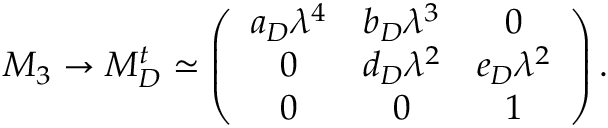<formula> <loc_0><loc_0><loc_500><loc_500>M _ { 3 } \rightarrow M _ { D } ^ { t } \simeq \left ( \begin{array} { c c c } { { a _ { D } \lambda ^ { 4 } } } & { { b _ { D } \lambda ^ { 3 } } } & { 0 } \\ { 0 } & { { d _ { D } \lambda ^ { 2 } } } & { { e _ { D } \lambda ^ { 2 } } } \\ { 0 } & { 0 } & { 1 } \end{array} \right ) .</formula> 